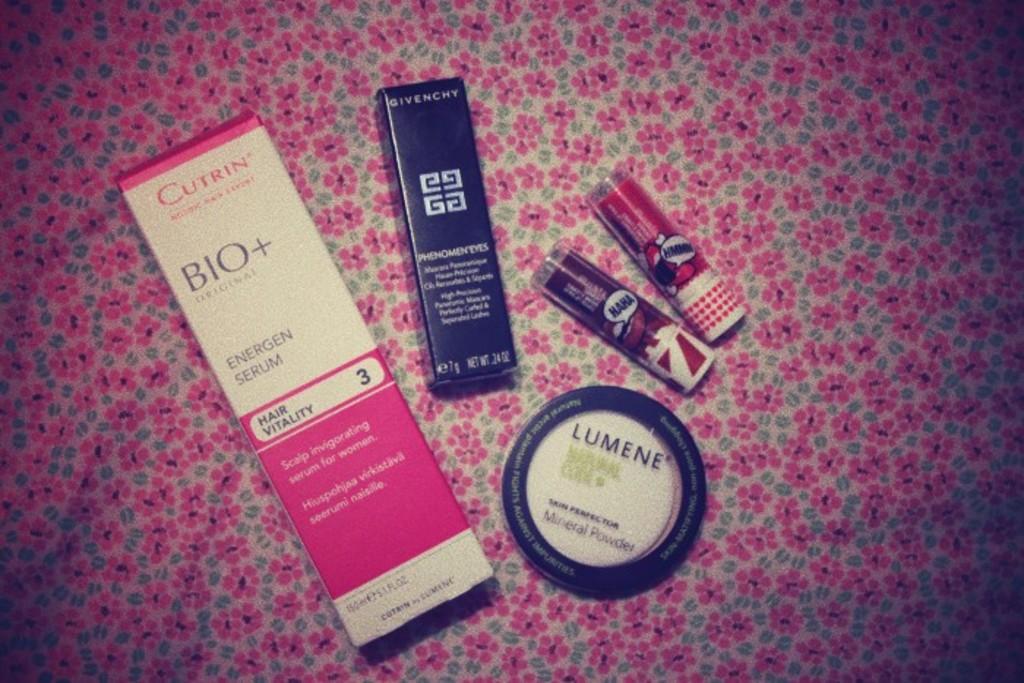Are these cosmetics from the same company?
Give a very brief answer. No. What company makes the pink box?
Ensure brevity in your answer.  Cutrin. 